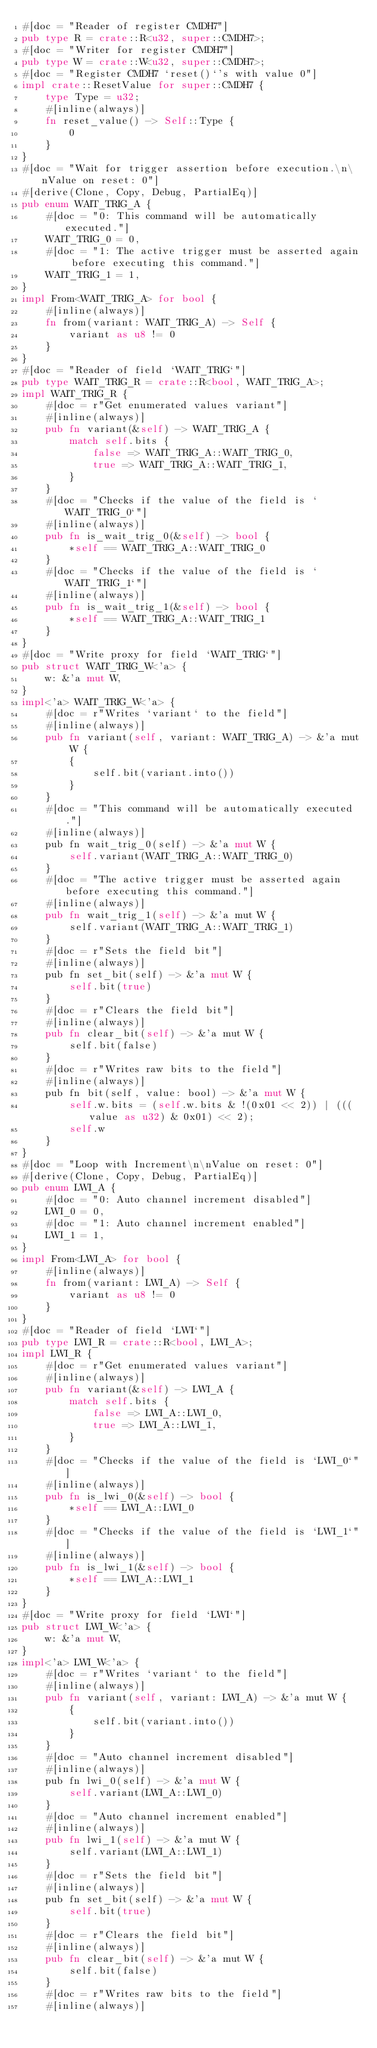<code> <loc_0><loc_0><loc_500><loc_500><_Rust_>#[doc = "Reader of register CMDH7"]
pub type R = crate::R<u32, super::CMDH7>;
#[doc = "Writer for register CMDH7"]
pub type W = crate::W<u32, super::CMDH7>;
#[doc = "Register CMDH7 `reset()`'s with value 0"]
impl crate::ResetValue for super::CMDH7 {
    type Type = u32;
    #[inline(always)]
    fn reset_value() -> Self::Type {
        0
    }
}
#[doc = "Wait for trigger assertion before execution.\n\nValue on reset: 0"]
#[derive(Clone, Copy, Debug, PartialEq)]
pub enum WAIT_TRIG_A {
    #[doc = "0: This command will be automatically executed."]
    WAIT_TRIG_0 = 0,
    #[doc = "1: The active trigger must be asserted again before executing this command."]
    WAIT_TRIG_1 = 1,
}
impl From<WAIT_TRIG_A> for bool {
    #[inline(always)]
    fn from(variant: WAIT_TRIG_A) -> Self {
        variant as u8 != 0
    }
}
#[doc = "Reader of field `WAIT_TRIG`"]
pub type WAIT_TRIG_R = crate::R<bool, WAIT_TRIG_A>;
impl WAIT_TRIG_R {
    #[doc = r"Get enumerated values variant"]
    #[inline(always)]
    pub fn variant(&self) -> WAIT_TRIG_A {
        match self.bits {
            false => WAIT_TRIG_A::WAIT_TRIG_0,
            true => WAIT_TRIG_A::WAIT_TRIG_1,
        }
    }
    #[doc = "Checks if the value of the field is `WAIT_TRIG_0`"]
    #[inline(always)]
    pub fn is_wait_trig_0(&self) -> bool {
        *self == WAIT_TRIG_A::WAIT_TRIG_0
    }
    #[doc = "Checks if the value of the field is `WAIT_TRIG_1`"]
    #[inline(always)]
    pub fn is_wait_trig_1(&self) -> bool {
        *self == WAIT_TRIG_A::WAIT_TRIG_1
    }
}
#[doc = "Write proxy for field `WAIT_TRIG`"]
pub struct WAIT_TRIG_W<'a> {
    w: &'a mut W,
}
impl<'a> WAIT_TRIG_W<'a> {
    #[doc = r"Writes `variant` to the field"]
    #[inline(always)]
    pub fn variant(self, variant: WAIT_TRIG_A) -> &'a mut W {
        {
            self.bit(variant.into())
        }
    }
    #[doc = "This command will be automatically executed."]
    #[inline(always)]
    pub fn wait_trig_0(self) -> &'a mut W {
        self.variant(WAIT_TRIG_A::WAIT_TRIG_0)
    }
    #[doc = "The active trigger must be asserted again before executing this command."]
    #[inline(always)]
    pub fn wait_trig_1(self) -> &'a mut W {
        self.variant(WAIT_TRIG_A::WAIT_TRIG_1)
    }
    #[doc = r"Sets the field bit"]
    #[inline(always)]
    pub fn set_bit(self) -> &'a mut W {
        self.bit(true)
    }
    #[doc = r"Clears the field bit"]
    #[inline(always)]
    pub fn clear_bit(self) -> &'a mut W {
        self.bit(false)
    }
    #[doc = r"Writes raw bits to the field"]
    #[inline(always)]
    pub fn bit(self, value: bool) -> &'a mut W {
        self.w.bits = (self.w.bits & !(0x01 << 2)) | (((value as u32) & 0x01) << 2);
        self.w
    }
}
#[doc = "Loop with Increment\n\nValue on reset: 0"]
#[derive(Clone, Copy, Debug, PartialEq)]
pub enum LWI_A {
    #[doc = "0: Auto channel increment disabled"]
    LWI_0 = 0,
    #[doc = "1: Auto channel increment enabled"]
    LWI_1 = 1,
}
impl From<LWI_A> for bool {
    #[inline(always)]
    fn from(variant: LWI_A) -> Self {
        variant as u8 != 0
    }
}
#[doc = "Reader of field `LWI`"]
pub type LWI_R = crate::R<bool, LWI_A>;
impl LWI_R {
    #[doc = r"Get enumerated values variant"]
    #[inline(always)]
    pub fn variant(&self) -> LWI_A {
        match self.bits {
            false => LWI_A::LWI_0,
            true => LWI_A::LWI_1,
        }
    }
    #[doc = "Checks if the value of the field is `LWI_0`"]
    #[inline(always)]
    pub fn is_lwi_0(&self) -> bool {
        *self == LWI_A::LWI_0
    }
    #[doc = "Checks if the value of the field is `LWI_1`"]
    #[inline(always)]
    pub fn is_lwi_1(&self) -> bool {
        *self == LWI_A::LWI_1
    }
}
#[doc = "Write proxy for field `LWI`"]
pub struct LWI_W<'a> {
    w: &'a mut W,
}
impl<'a> LWI_W<'a> {
    #[doc = r"Writes `variant` to the field"]
    #[inline(always)]
    pub fn variant(self, variant: LWI_A) -> &'a mut W {
        {
            self.bit(variant.into())
        }
    }
    #[doc = "Auto channel increment disabled"]
    #[inline(always)]
    pub fn lwi_0(self) -> &'a mut W {
        self.variant(LWI_A::LWI_0)
    }
    #[doc = "Auto channel increment enabled"]
    #[inline(always)]
    pub fn lwi_1(self) -> &'a mut W {
        self.variant(LWI_A::LWI_1)
    }
    #[doc = r"Sets the field bit"]
    #[inline(always)]
    pub fn set_bit(self) -> &'a mut W {
        self.bit(true)
    }
    #[doc = r"Clears the field bit"]
    #[inline(always)]
    pub fn clear_bit(self) -> &'a mut W {
        self.bit(false)
    }
    #[doc = r"Writes raw bits to the field"]
    #[inline(always)]</code> 